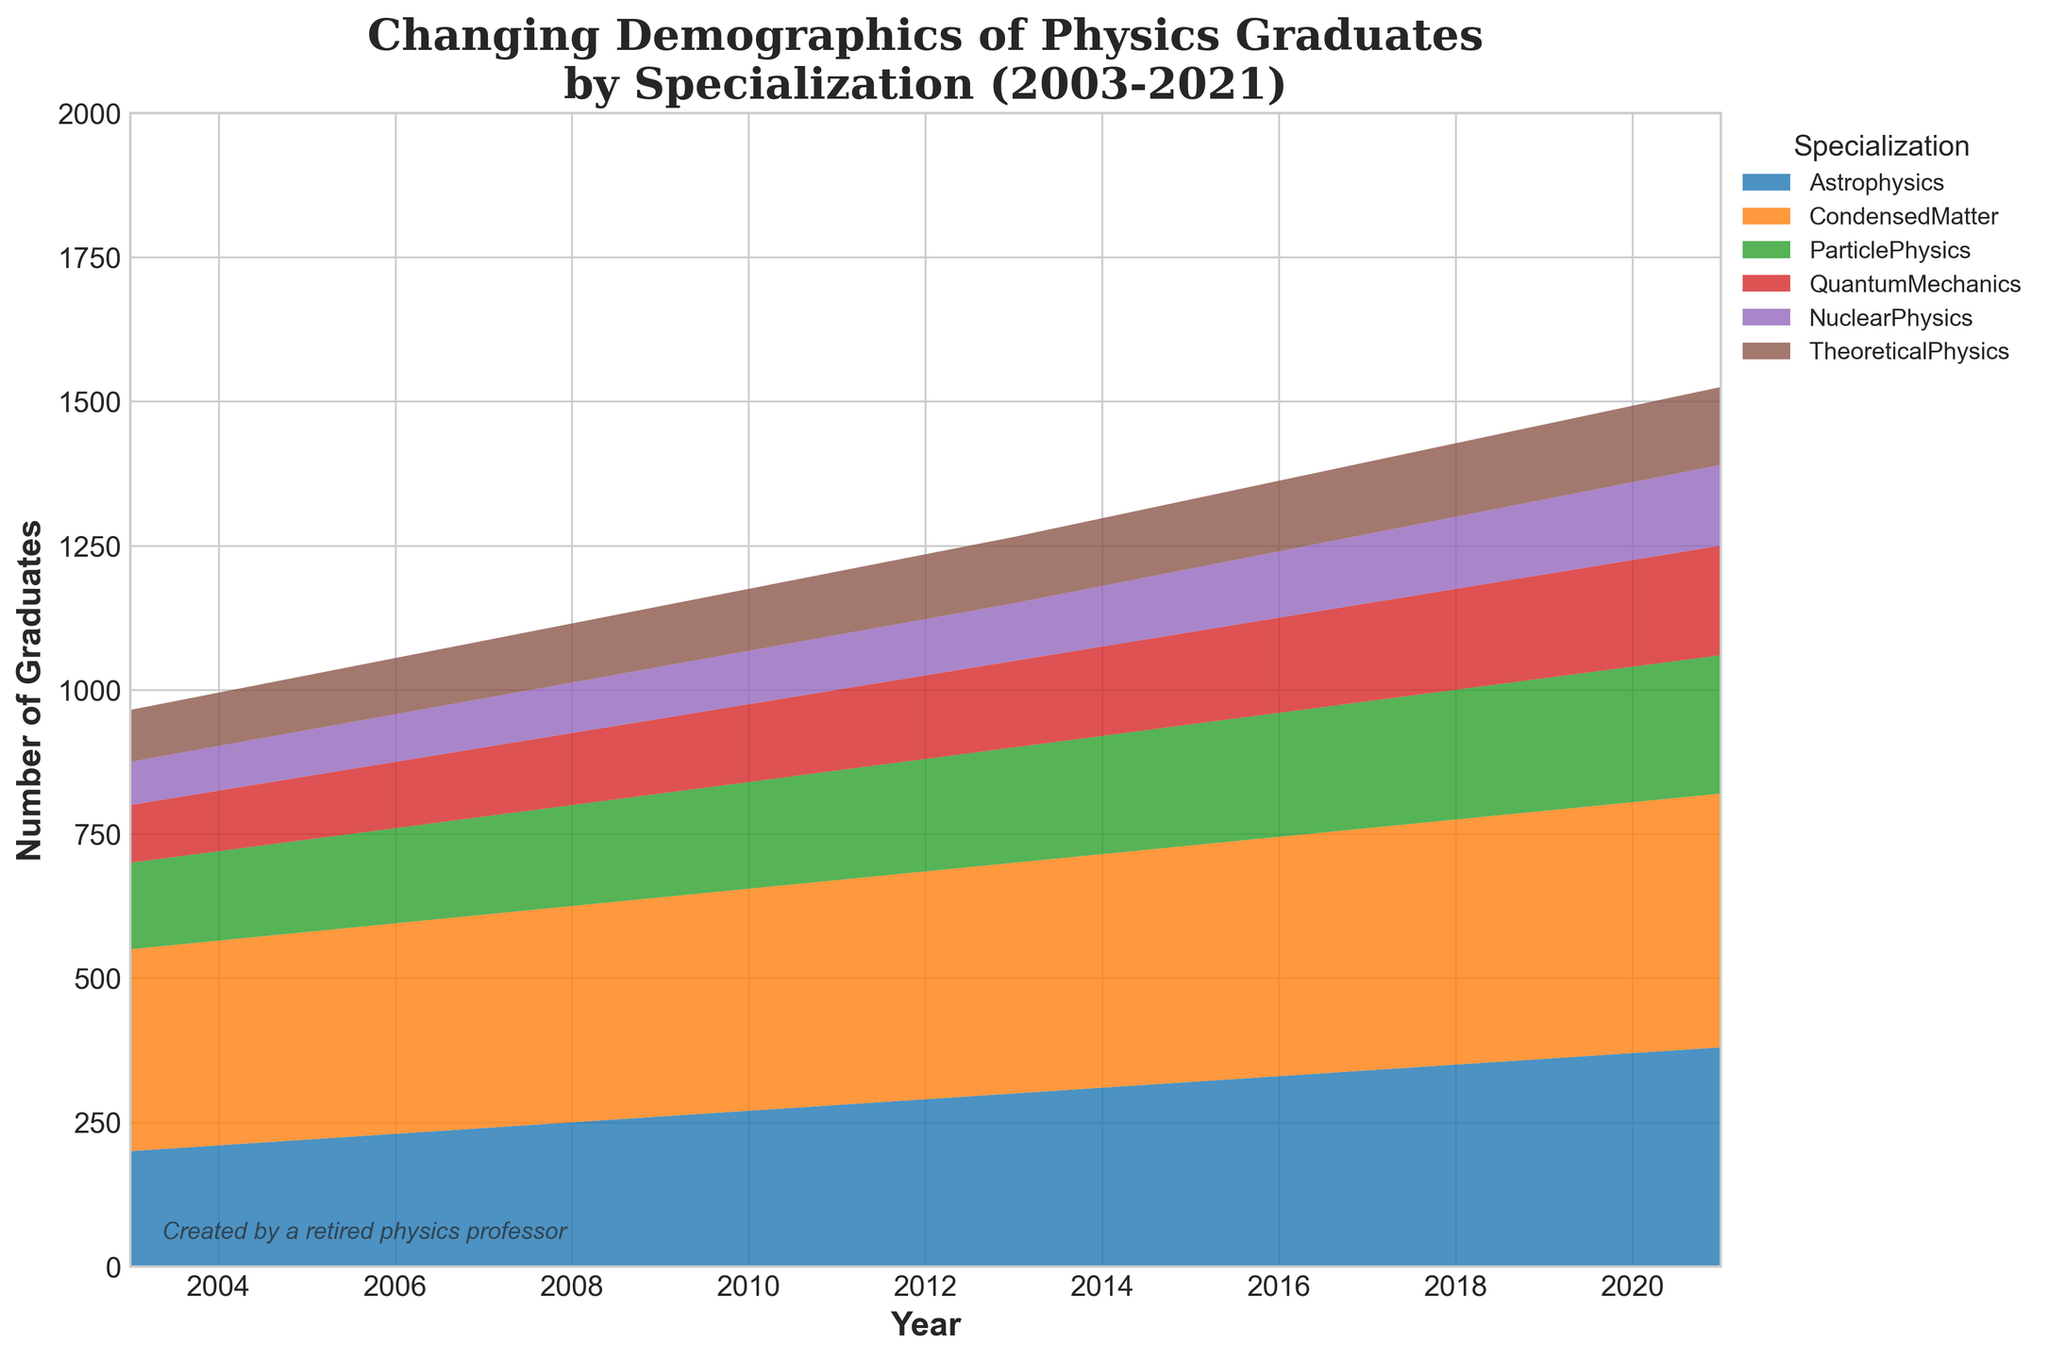What is the title of the figure? The title of the figure is usually found at the top. In this figure, it reads "Changing Demographics of Physics Graduates by Specialization (2003-2021)".
Answer: Changing Demographics of Physics Graduates by Specialization (2003-2021) How many specializations are represented in the figure? By looking at the legend or the different colored areas in the chart, we can count the number of specializations. There are 6 specializations represented.
Answer: 6 Which specialization had the highest number of graduates in 2021? By looking at the topmost section of the area chart for the year 2021, we can see which specialization is at the highest point. The Condensed Matter specialization had the highest number.
Answer: Condensed Matter What is the range of years represented in the figure? The x-axis of the area chart shows the range of years. The data spans from the year 2003 to 2021.
Answer: 2003 to 2021 In which year did Particle Physics graduates surpass 200? Observing the area representing Particle Physics, we look for the year at which this area first exceeds the 200 mark. This occurs in 2013.
Answer: 2013 What is the increase in the number of Astrophysics graduates from 2003 to 2021? In 2003, there were 200 Astrophysics graduates. In 2021, there were 380. The increase is calculated as 380 - 200 = 180.
Answer: 180 Which specialization had the least number of graduates in 2005? By comparing the areas for each specialization in 2005, the smallest section represents Nuclear Physics with 80 graduates.
Answer: Nuclear Physics Did Quantum Mechanics graduates ever exceed 150 in any year? If so, in which year did they first exceed this number? Observing the area representing Quantum Mechanics, it first surpasses 150 in the year 2013.
Answer: 2013 How does the trend in the number of Theoretical Physics graduates compare to that of Nuclear Physics graduates over the years? By observing the stacked areas for both Theoretical Physics and Nuclear Physics, we notice that both have a general upward trend, but Theoretical Physics showed a steadier increase compared to the smaller growth of Nuclear Physics.
Answer: Theoretical Physics had a steadier increase compared to Nuclear Physics 